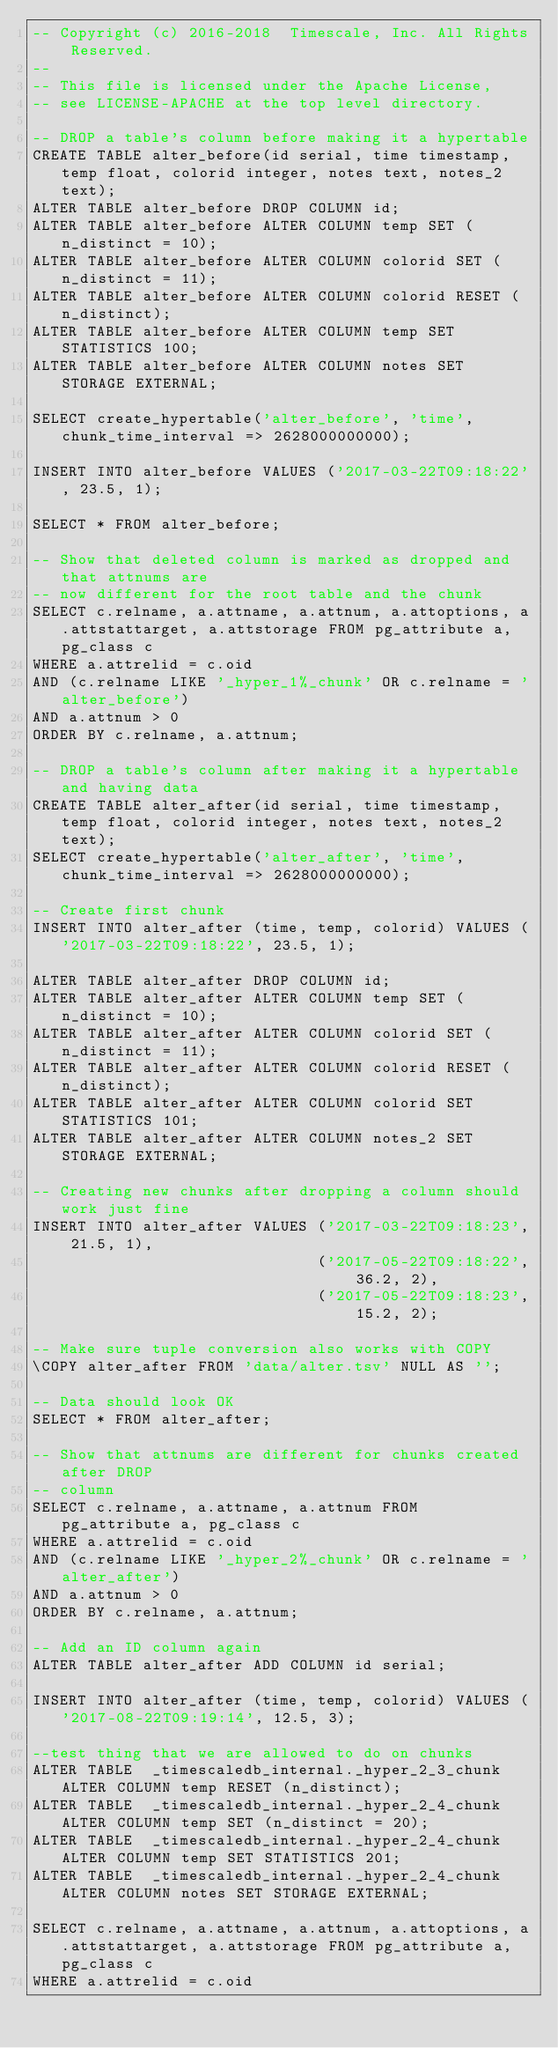Convert code to text. <code><loc_0><loc_0><loc_500><loc_500><_SQL_>-- Copyright (c) 2016-2018  Timescale, Inc. All Rights Reserved.
--
-- This file is licensed under the Apache License,
-- see LICENSE-APACHE at the top level directory.

-- DROP a table's column before making it a hypertable
CREATE TABLE alter_before(id serial, time timestamp, temp float, colorid integer, notes text, notes_2 text);
ALTER TABLE alter_before DROP COLUMN id;
ALTER TABLE alter_before ALTER COLUMN temp SET (n_distinct = 10);
ALTER TABLE alter_before ALTER COLUMN colorid SET (n_distinct = 11);
ALTER TABLE alter_before ALTER COLUMN colorid RESET (n_distinct);
ALTER TABLE alter_before ALTER COLUMN temp SET STATISTICS 100;
ALTER TABLE alter_before ALTER COLUMN notes SET STORAGE EXTERNAL;

SELECT create_hypertable('alter_before', 'time', chunk_time_interval => 2628000000000);

INSERT INTO alter_before VALUES ('2017-03-22T09:18:22', 23.5, 1);

SELECT * FROM alter_before;

-- Show that deleted column is marked as dropped and that attnums are
-- now different for the root table and the chunk
SELECT c.relname, a.attname, a.attnum, a.attoptions, a.attstattarget, a.attstorage FROM pg_attribute a, pg_class c
WHERE a.attrelid = c.oid
AND (c.relname LIKE '_hyper_1%_chunk' OR c.relname = 'alter_before')
AND a.attnum > 0
ORDER BY c.relname, a.attnum;

-- DROP a table's column after making it a hypertable and having data
CREATE TABLE alter_after(id serial, time timestamp, temp float, colorid integer, notes text, notes_2 text);
SELECT create_hypertable('alter_after', 'time', chunk_time_interval => 2628000000000);

-- Create first chunk
INSERT INTO alter_after (time, temp, colorid) VALUES ('2017-03-22T09:18:22', 23.5, 1);

ALTER TABLE alter_after DROP COLUMN id;
ALTER TABLE alter_after ALTER COLUMN temp SET (n_distinct = 10);
ALTER TABLE alter_after ALTER COLUMN colorid SET (n_distinct = 11);
ALTER TABLE alter_after ALTER COLUMN colorid RESET (n_distinct);
ALTER TABLE alter_after ALTER COLUMN colorid SET STATISTICS 101;
ALTER TABLE alter_after ALTER COLUMN notes_2 SET STORAGE EXTERNAL;

-- Creating new chunks after dropping a column should work just fine
INSERT INTO alter_after VALUES ('2017-03-22T09:18:23', 21.5, 1),
                               ('2017-05-22T09:18:22', 36.2, 2),
                               ('2017-05-22T09:18:23', 15.2, 2);

-- Make sure tuple conversion also works with COPY
\COPY alter_after FROM 'data/alter.tsv' NULL AS '';

-- Data should look OK
SELECT * FROM alter_after;

-- Show that attnums are different for chunks created after DROP
-- column
SELECT c.relname, a.attname, a.attnum FROM pg_attribute a, pg_class c
WHERE a.attrelid = c.oid
AND (c.relname LIKE '_hyper_2%_chunk' OR c.relname = 'alter_after')
AND a.attnum > 0
ORDER BY c.relname, a.attnum;

-- Add an ID column again
ALTER TABLE alter_after ADD COLUMN id serial;

INSERT INTO alter_after (time, temp, colorid) VALUES ('2017-08-22T09:19:14', 12.5, 3);

--test thing that we are allowed to do on chunks
ALTER TABLE  _timescaledb_internal._hyper_2_3_chunk ALTER COLUMN temp RESET (n_distinct);
ALTER TABLE  _timescaledb_internal._hyper_2_4_chunk ALTER COLUMN temp SET (n_distinct = 20);
ALTER TABLE  _timescaledb_internal._hyper_2_4_chunk ALTER COLUMN temp SET STATISTICS 201;
ALTER TABLE  _timescaledb_internal._hyper_2_4_chunk ALTER COLUMN notes SET STORAGE EXTERNAL;

SELECT c.relname, a.attname, a.attnum, a.attoptions, a.attstattarget, a.attstorage FROM pg_attribute a, pg_class c
WHERE a.attrelid = c.oid</code> 